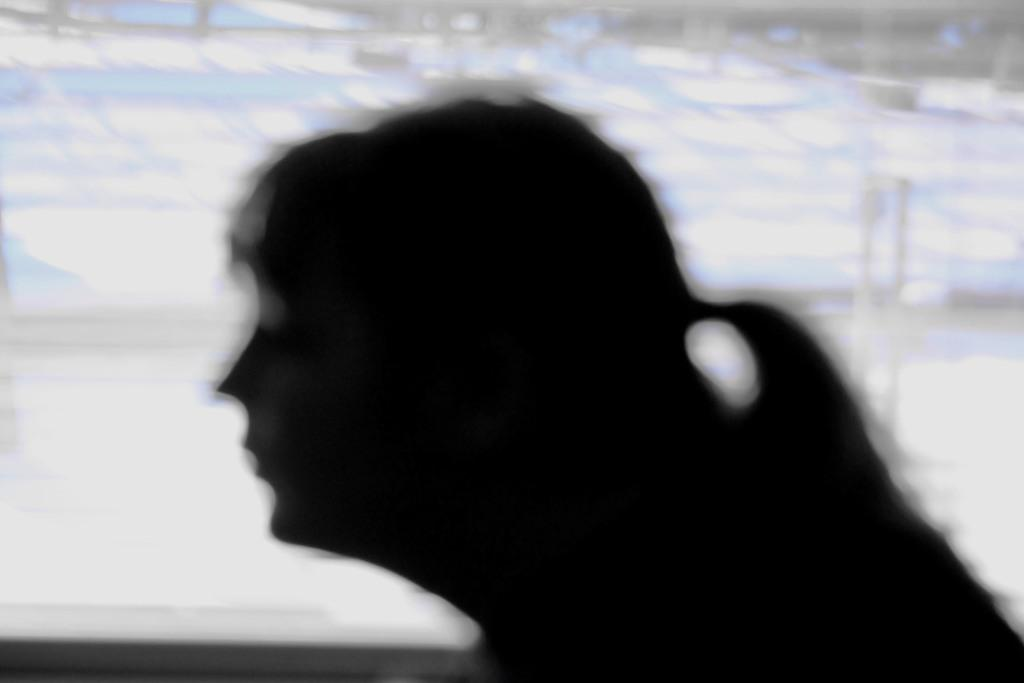What is the main subject of the picture? The main subject of the picture is a blurred image of a woman. How many mice are visible in the image? There are no mice present in the image; it features a blurred image of a woman. What type of bean is being used to represent wealth in the image? There is no bean present in the image, and the concept of wealth is not depicted. 